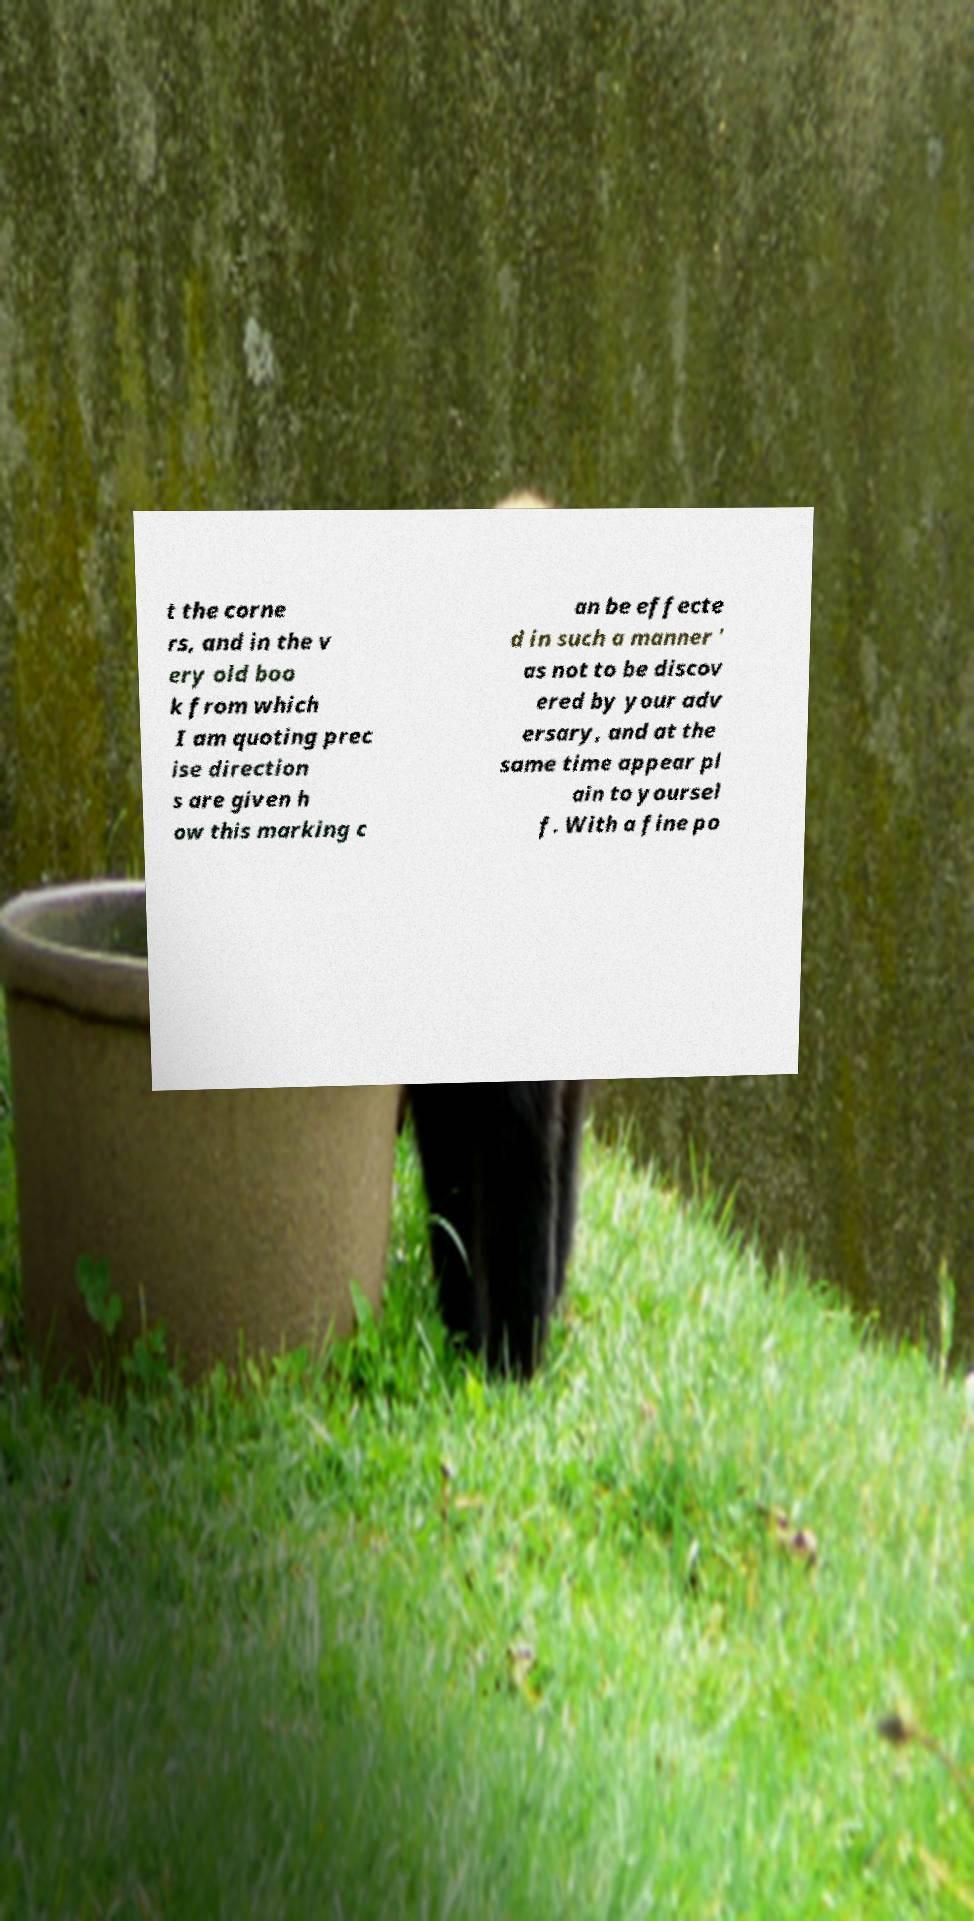Could you extract and type out the text from this image? t the corne rs, and in the v ery old boo k from which I am quoting prec ise direction s are given h ow this marking c an be effecte d in such a manner ' as not to be discov ered by your adv ersary, and at the same time appear pl ain to yoursel f. With a fine po 